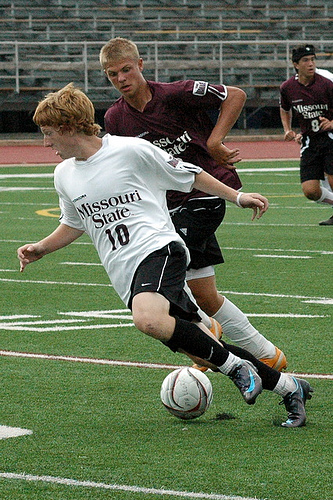<image>
Is there a boy under the ball? No. The boy is not positioned under the ball. The vertical relationship between these objects is different. Where is the ball in relation to the player? Is it behind the player? No. The ball is not behind the player. From this viewpoint, the ball appears to be positioned elsewhere in the scene. Where is the ball in relation to the turf? Is it above the turf? Yes. The ball is positioned above the turf in the vertical space, higher up in the scene. 